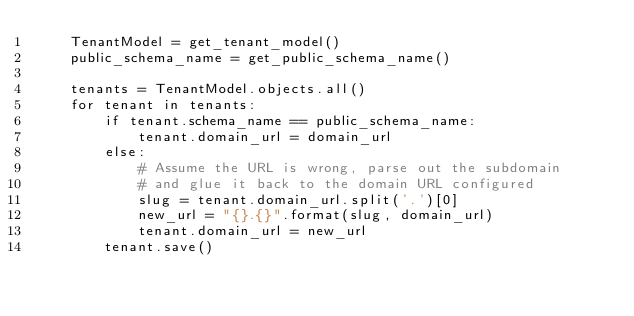<code> <loc_0><loc_0><loc_500><loc_500><_Python_>    TenantModel = get_tenant_model()
    public_schema_name = get_public_schema_name()

    tenants = TenantModel.objects.all()
    for tenant in tenants:
        if tenant.schema_name == public_schema_name:
            tenant.domain_url = domain_url
        else:
            # Assume the URL is wrong, parse out the subdomain
            # and glue it back to the domain URL configured
            slug = tenant.domain_url.split('.')[0]
            new_url = "{}.{}".format(slug, domain_url)
            tenant.domain_url = new_url
        tenant.save()
</code> 